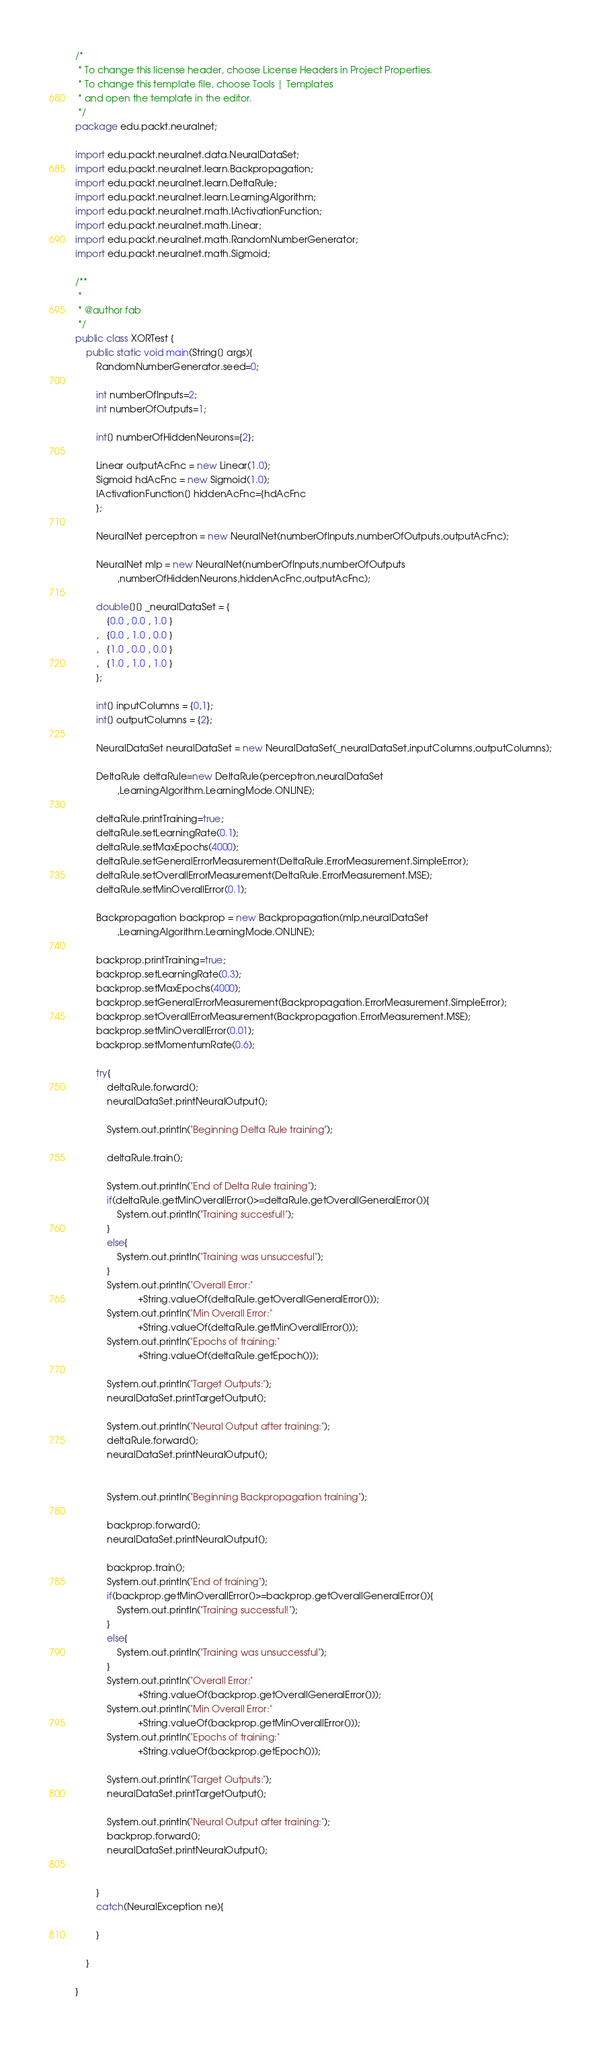Convert code to text. <code><loc_0><loc_0><loc_500><loc_500><_Java_>/*
 * To change this license header, choose License Headers in Project Properties.
 * To change this template file, choose Tools | Templates
 * and open the template in the editor.
 */
package edu.packt.neuralnet;

import edu.packt.neuralnet.data.NeuralDataSet;
import edu.packt.neuralnet.learn.Backpropagation;
import edu.packt.neuralnet.learn.DeltaRule;
import edu.packt.neuralnet.learn.LearningAlgorithm;
import edu.packt.neuralnet.math.IActivationFunction;
import edu.packt.neuralnet.math.Linear;
import edu.packt.neuralnet.math.RandomNumberGenerator;
import edu.packt.neuralnet.math.Sigmoid;

/**
 *
 * @author fab
 */
public class XORTest {
    public static void main(String[] args){
        RandomNumberGenerator.seed=0;
        
        int numberOfInputs=2;
        int numberOfOutputs=1;
        
        int[] numberOfHiddenNeurons={2};
        
        Linear outputAcFnc = new Linear(1.0);
        Sigmoid hdAcFnc = new Sigmoid(1.0);
        IActivationFunction[] hiddenAcFnc={hdAcFnc
        };
        
        NeuralNet perceptron = new NeuralNet(numberOfInputs,numberOfOutputs,outputAcFnc);

        NeuralNet mlp = new NeuralNet(numberOfInputs,numberOfOutputs
                ,numberOfHiddenNeurons,hiddenAcFnc,outputAcFnc);
        
        double[][] _neuralDataSet = {
            {0.0 , 0.0 , 1.0 }
        ,   {0.0 , 1.0 , 0.0 }
        ,   {1.0 , 0.0 , 0.0 }
        ,   {1.0 , 1.0 , 1.0 }
        };
        
        int[] inputColumns = {0,1};
        int[] outputColumns = {2};
        
        NeuralDataSet neuralDataSet = new NeuralDataSet(_neuralDataSet,inputColumns,outputColumns);
        
        DeltaRule deltaRule=new DeltaRule(perceptron,neuralDataSet
                ,LearningAlgorithm.LearningMode.ONLINE);
        
        deltaRule.printTraining=true;
        deltaRule.setLearningRate(0.1);
        deltaRule.setMaxEpochs(4000);
        deltaRule.setGeneralErrorMeasurement(DeltaRule.ErrorMeasurement.SimpleError);
        deltaRule.setOverallErrorMeasurement(DeltaRule.ErrorMeasurement.MSE);
        deltaRule.setMinOverallError(0.1);
        
        Backpropagation backprop = new Backpropagation(mlp,neuralDataSet
                ,LearningAlgorithm.LearningMode.ONLINE);
        
        backprop.printTraining=true;
        backprop.setLearningRate(0.3);
        backprop.setMaxEpochs(4000);
        backprop.setGeneralErrorMeasurement(Backpropagation.ErrorMeasurement.SimpleError);
        backprop.setOverallErrorMeasurement(Backpropagation.ErrorMeasurement.MSE);
        backprop.setMinOverallError(0.01);
        backprop.setMomentumRate(0.6);
        
        try{
            deltaRule.forward();
            neuralDataSet.printNeuralOutput();
            
            System.out.println("Beginning Delta Rule training");
            
            deltaRule.train();
            
            System.out.println("End of Delta Rule training");
            if(deltaRule.getMinOverallError()>=deltaRule.getOverallGeneralError()){
                System.out.println("Training succesful!");
            }
            else{
                System.out.println("Training was unsuccesful");
            }
            System.out.println("Overall Error:"
                        +String.valueOf(deltaRule.getOverallGeneralError()));
            System.out.println("Min Overall Error:"
                        +String.valueOf(deltaRule.getMinOverallError()));
            System.out.println("Epochs of training:"
                        +String.valueOf(deltaRule.getEpoch()));
            
            System.out.println("Target Outputs:");
            neuralDataSet.printTargetOutput();
            
            System.out.println("Neural Output after training:");
            deltaRule.forward();
            neuralDataSet.printNeuralOutput();
            
            
            System.out.println("Beginning Backpropagation training");
            
            backprop.forward();
            neuralDataSet.printNeuralOutput();
            
            backprop.train();
            System.out.println("End of training");
            if(backprop.getMinOverallError()>=backprop.getOverallGeneralError()){
                System.out.println("Training successful!");
            }
            else{
                System.out.println("Training was unsuccessful");
            }
            System.out.println("Overall Error:"
                        +String.valueOf(backprop.getOverallGeneralError()));
            System.out.println("Min Overall Error:"
                        +String.valueOf(backprop.getMinOverallError()));
            System.out.println("Epochs of training:"
                        +String.valueOf(backprop.getEpoch()));
            
            System.out.println("Target Outputs:");
            neuralDataSet.printTargetOutput();
            
            System.out.println("Neural Output after training:");
            backprop.forward();
            neuralDataSet.printNeuralOutput();

            
        }
        catch(NeuralException ne){
            
        }
        
    }
    
}
</code> 